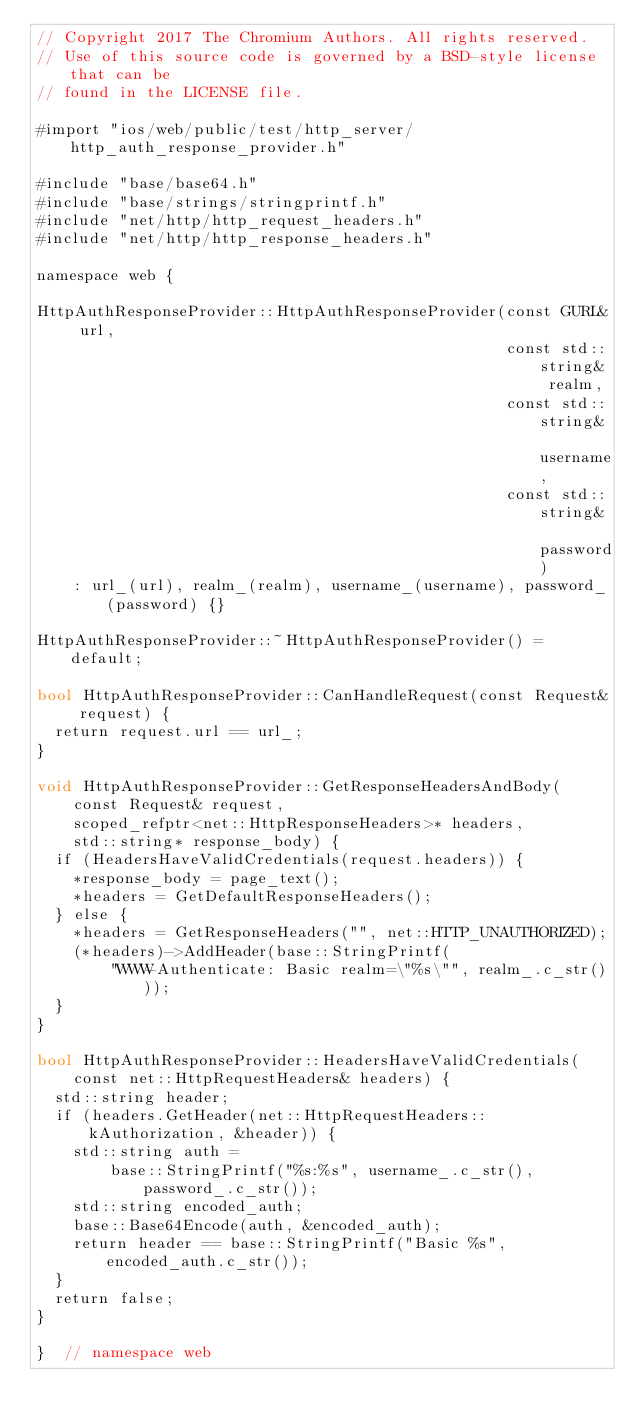Convert code to text. <code><loc_0><loc_0><loc_500><loc_500><_ObjectiveC_>// Copyright 2017 The Chromium Authors. All rights reserved.
// Use of this source code is governed by a BSD-style license that can be
// found in the LICENSE file.

#import "ios/web/public/test/http_server/http_auth_response_provider.h"

#include "base/base64.h"
#include "base/strings/stringprintf.h"
#include "net/http/http_request_headers.h"
#include "net/http/http_response_headers.h"

namespace web {

HttpAuthResponseProvider::HttpAuthResponseProvider(const GURL& url,
                                                   const std::string& realm,
                                                   const std::string& username,
                                                   const std::string& password)
    : url_(url), realm_(realm), username_(username), password_(password) {}

HttpAuthResponseProvider::~HttpAuthResponseProvider() = default;

bool HttpAuthResponseProvider::CanHandleRequest(const Request& request) {
  return request.url == url_;
}

void HttpAuthResponseProvider::GetResponseHeadersAndBody(
    const Request& request,
    scoped_refptr<net::HttpResponseHeaders>* headers,
    std::string* response_body) {
  if (HeadersHaveValidCredentials(request.headers)) {
    *response_body = page_text();
    *headers = GetDefaultResponseHeaders();
  } else {
    *headers = GetResponseHeaders("", net::HTTP_UNAUTHORIZED);
    (*headers)->AddHeader(base::StringPrintf(
        "WWW-Authenticate: Basic realm=\"%s\"", realm_.c_str()));
  }
}

bool HttpAuthResponseProvider::HeadersHaveValidCredentials(
    const net::HttpRequestHeaders& headers) {
  std::string header;
  if (headers.GetHeader(net::HttpRequestHeaders::kAuthorization, &header)) {
    std::string auth =
        base::StringPrintf("%s:%s", username_.c_str(), password_.c_str());
    std::string encoded_auth;
    base::Base64Encode(auth, &encoded_auth);
    return header == base::StringPrintf("Basic %s", encoded_auth.c_str());
  }
  return false;
}

}  // namespace web
</code> 